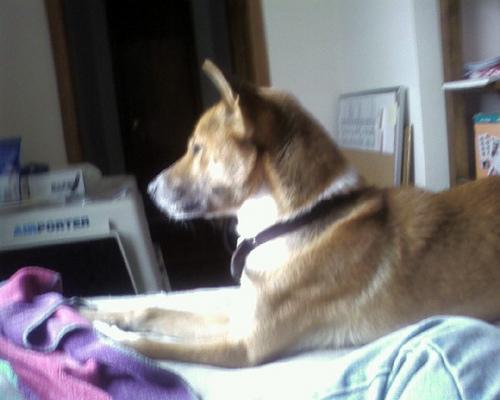Will this dog jump?
Short answer required. No. What does the collar say?
Concise answer only. Nothing. Is the dog wearing a collar?
Give a very brief answer. Yes. 